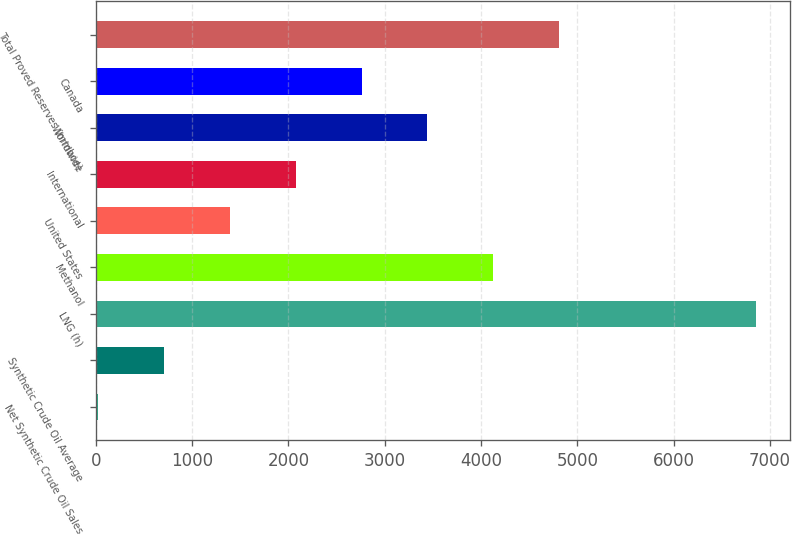Convert chart to OTSL. <chart><loc_0><loc_0><loc_500><loc_500><bar_chart><fcel>Net Synthetic Crude Oil Sales<fcel>Synthetic Crude Oil Average<fcel>LNG (h)<fcel>Methanol<fcel>United States<fcel>International<fcel>Worldwide<fcel>Canada<fcel>Total Proved Reserves (mmboe)<nl><fcel>29<fcel>712<fcel>6859<fcel>4127<fcel>1395<fcel>2078<fcel>3444<fcel>2761<fcel>4810<nl></chart> 